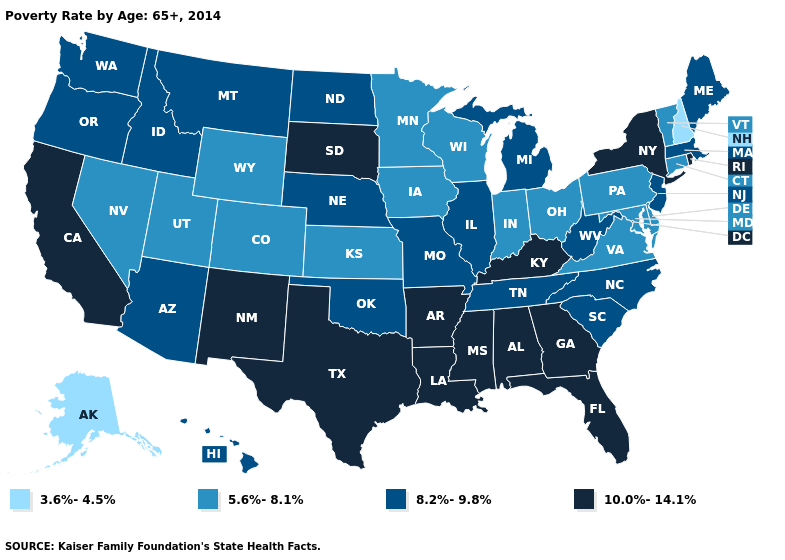How many symbols are there in the legend?
Concise answer only. 4. What is the value of Delaware?
Concise answer only. 5.6%-8.1%. How many symbols are there in the legend?
Keep it brief. 4. What is the lowest value in the USA?
Give a very brief answer. 3.6%-4.5%. Which states have the highest value in the USA?
Answer briefly. Alabama, Arkansas, California, Florida, Georgia, Kentucky, Louisiana, Mississippi, New Mexico, New York, Rhode Island, South Dakota, Texas. What is the value of North Dakota?
Answer briefly. 8.2%-9.8%. What is the value of Texas?
Give a very brief answer. 10.0%-14.1%. Name the states that have a value in the range 8.2%-9.8%?
Be succinct. Arizona, Hawaii, Idaho, Illinois, Maine, Massachusetts, Michigan, Missouri, Montana, Nebraska, New Jersey, North Carolina, North Dakota, Oklahoma, Oregon, South Carolina, Tennessee, Washington, West Virginia. Among the states that border South Dakota , does Nebraska have the highest value?
Concise answer only. Yes. Name the states that have a value in the range 10.0%-14.1%?
Answer briefly. Alabama, Arkansas, California, Florida, Georgia, Kentucky, Louisiana, Mississippi, New Mexico, New York, Rhode Island, South Dakota, Texas. Name the states that have a value in the range 10.0%-14.1%?
Give a very brief answer. Alabama, Arkansas, California, Florida, Georgia, Kentucky, Louisiana, Mississippi, New Mexico, New York, Rhode Island, South Dakota, Texas. Among the states that border South Dakota , does Minnesota have the lowest value?
Give a very brief answer. Yes. Which states hav the highest value in the West?
Quick response, please. California, New Mexico. Name the states that have a value in the range 5.6%-8.1%?
Concise answer only. Colorado, Connecticut, Delaware, Indiana, Iowa, Kansas, Maryland, Minnesota, Nevada, Ohio, Pennsylvania, Utah, Vermont, Virginia, Wisconsin, Wyoming. What is the lowest value in states that border Missouri?
Short answer required. 5.6%-8.1%. 